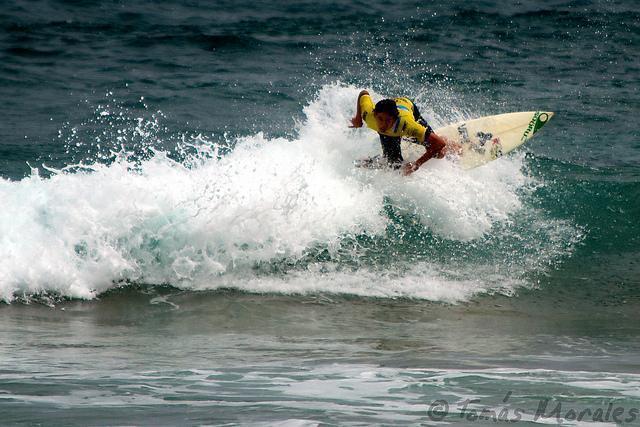How many sandwiches are there?
Give a very brief answer. 0. 